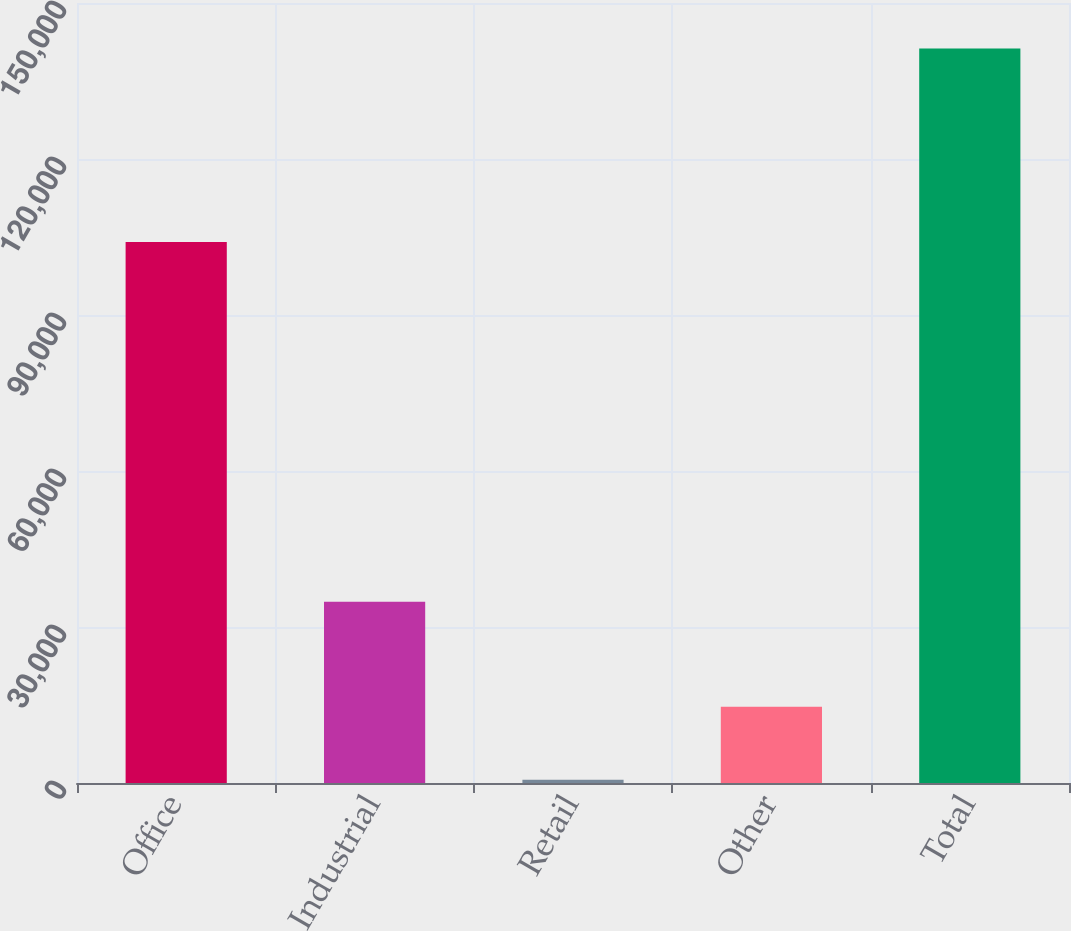Convert chart. <chart><loc_0><loc_0><loc_500><loc_500><bar_chart><fcel>Office<fcel>Industrial<fcel>Retail<fcel>Other<fcel>Total<nl><fcel>104056<fcel>34872<fcel>609<fcel>14670.7<fcel>141226<nl></chart> 